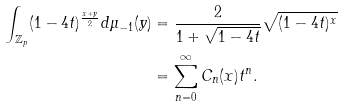<formula> <loc_0><loc_0><loc_500><loc_500>\int _ { \mathbb { Z } _ { p } } ( 1 - 4 t ) ^ { \frac { x + y } { 2 } } d \mu _ { - 1 } ( y ) & = \frac { 2 } { 1 + \sqrt { 1 - 4 t } } \sqrt { ( 1 - 4 t ) ^ { x } } \\ & = \sum _ { n = 0 } ^ { \infty } C _ { n } ( x ) t ^ { n } .</formula> 